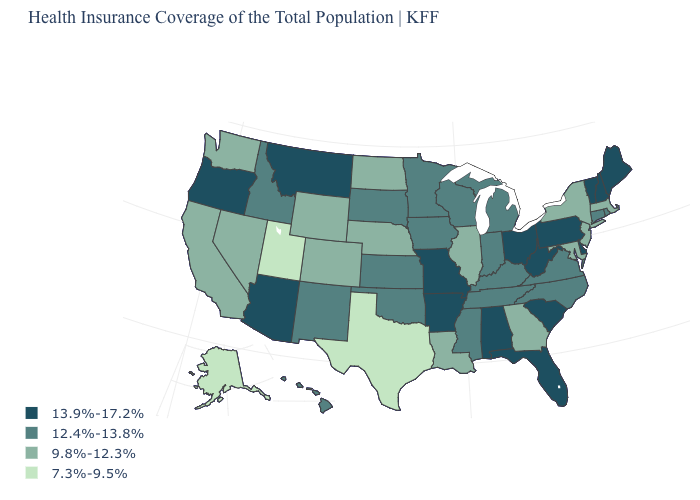Name the states that have a value in the range 7.3%-9.5%?
Quick response, please. Alaska, Texas, Utah. What is the value of Ohio?
Answer briefly. 13.9%-17.2%. What is the value of Washington?
Write a very short answer. 9.8%-12.3%. Which states have the highest value in the USA?
Quick response, please. Alabama, Arizona, Arkansas, Delaware, Florida, Maine, Missouri, Montana, New Hampshire, Ohio, Oregon, Pennsylvania, South Carolina, Vermont, West Virginia. Name the states that have a value in the range 13.9%-17.2%?
Answer briefly. Alabama, Arizona, Arkansas, Delaware, Florida, Maine, Missouri, Montana, New Hampshire, Ohio, Oregon, Pennsylvania, South Carolina, Vermont, West Virginia. How many symbols are there in the legend?
Be succinct. 4. What is the value of Wyoming?
Give a very brief answer. 9.8%-12.3%. Which states have the lowest value in the South?
Concise answer only. Texas. Does the first symbol in the legend represent the smallest category?
Quick response, please. No. How many symbols are there in the legend?
Be succinct. 4. Among the states that border Pennsylvania , which have the highest value?
Answer briefly. Delaware, Ohio, West Virginia. What is the value of Minnesota?
Write a very short answer. 12.4%-13.8%. Does Texas have the lowest value in the USA?
Quick response, please. Yes. Does Maine have the highest value in the USA?
Answer briefly. Yes. What is the highest value in the USA?
Concise answer only. 13.9%-17.2%. 